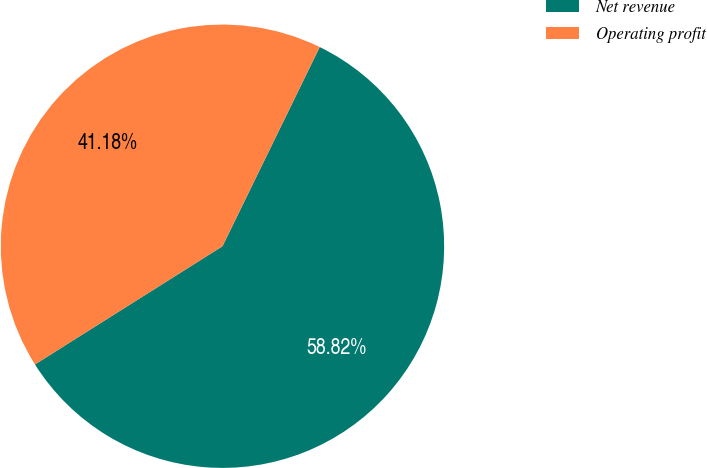Convert chart. <chart><loc_0><loc_0><loc_500><loc_500><pie_chart><fcel>Net revenue<fcel>Operating profit<nl><fcel>58.82%<fcel>41.18%<nl></chart> 